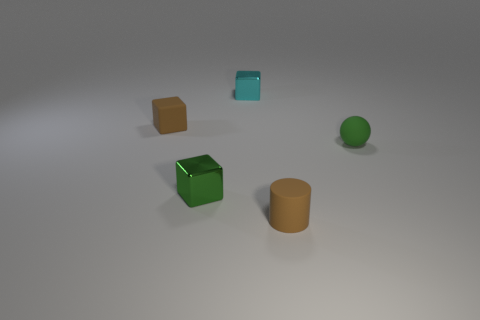Add 1 brown matte cylinders. How many objects exist? 6 Subtract all cubes. How many objects are left? 2 Add 1 small brown matte cylinders. How many small brown matte cylinders exist? 2 Subtract 1 cyan cubes. How many objects are left? 4 Subtract all big blue matte balls. Subtract all small green balls. How many objects are left? 4 Add 4 brown rubber cylinders. How many brown rubber cylinders are left? 5 